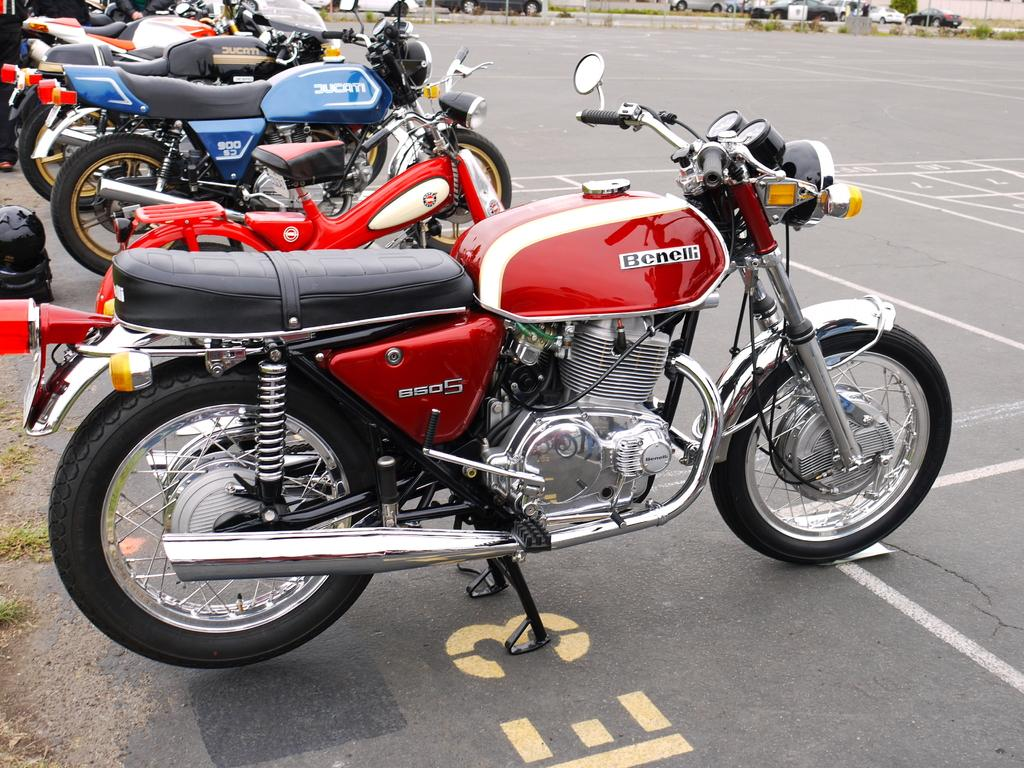What is the main subject of the picture? The main subject of the picture is bikes. How are the bikes arranged in the image? The bikes are arranged in an order. What can be observed about the appearance of the bikes? The bikes are of different colors. What type of orange can be seen growing on the bikes in the image? There is no orange present in the image; it features bikes of different colors arranged in an order. 